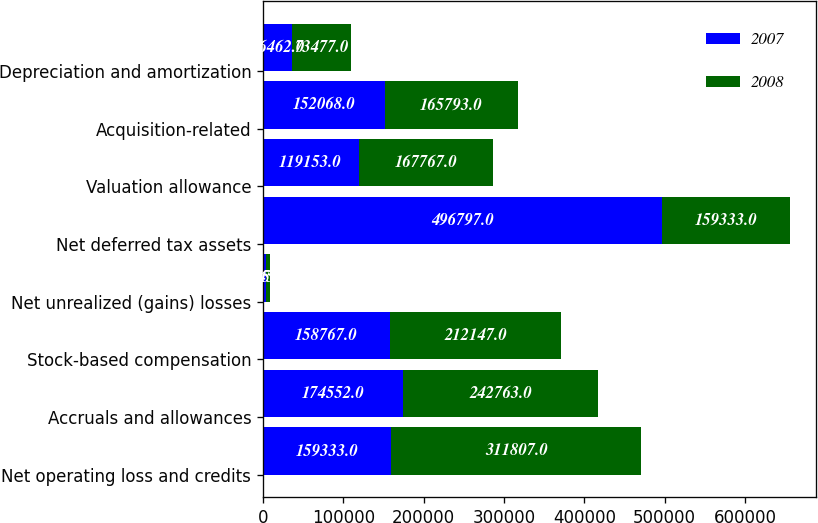Convert chart to OTSL. <chart><loc_0><loc_0><loc_500><loc_500><stacked_bar_chart><ecel><fcel>Net operating loss and credits<fcel>Accruals and allowances<fcel>Stock-based compensation<fcel>Net unrealized (gains) losses<fcel>Net deferred tax assets<fcel>Valuation allowance<fcel>Acquisition-related<fcel>Depreciation and amortization<nl><fcel>2007<fcel>159333<fcel>174552<fcel>158767<fcel>4145<fcel>496797<fcel>119153<fcel>152068<fcel>36462<nl><fcel>2008<fcel>311807<fcel>242763<fcel>212147<fcel>4052<fcel>159333<fcel>167767<fcel>165793<fcel>73477<nl></chart> 